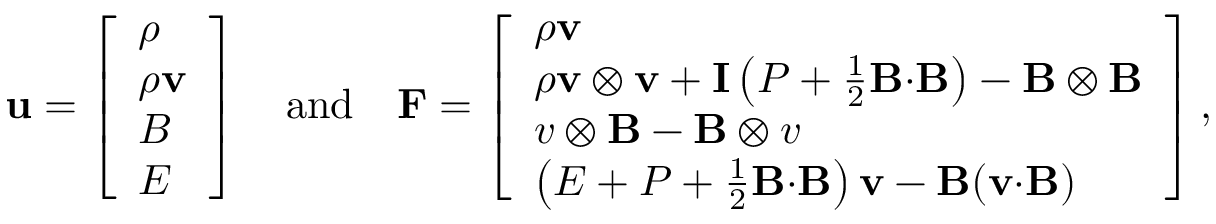<formula> <loc_0><loc_0><loc_500><loc_500>u = \left [ \begin{array} { l } { \rho } \\ { \rho v } \\ { B } \\ { E } \end{array} \right ] \quad a n d \quad F = \left [ \begin{array} { l } { \rho v } \\ { \rho v \otimes v + I \left ( P + \frac { 1 } { 2 } B { \cdot } B \right ) - B \otimes B } \\ { v \otimes B - B \otimes v } \\ { \left ( E + P + \frac { 1 } { 2 } B { \cdot } B \right ) v - B ( v { \cdot } B ) } \end{array} \right ] ,</formula> 